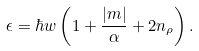<formula> <loc_0><loc_0><loc_500><loc_500>\epsilon = \hbar { w } \left ( 1 + \frac { \left | m \right | } { \alpha } + 2 n _ { \rho } \right ) .</formula> 